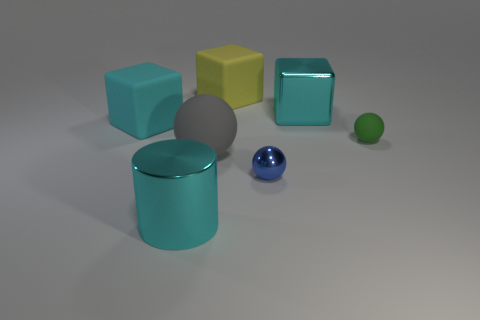Are there fewer shiny cubes that are behind the blue metal thing than blue balls?
Keep it short and to the point. No. What is the shape of the large cyan thing that is to the right of the large cyan cylinder?
Provide a succinct answer. Cube. What is the shape of the other matte object that is the same size as the blue object?
Ensure brevity in your answer.  Sphere. Is there another big rubber object of the same shape as the blue object?
Offer a very short reply. Yes. Is the shape of the big cyan object left of the metallic cylinder the same as the large cyan object that is right of the large gray object?
Provide a short and direct response. Yes. There is a green object that is the same size as the blue sphere; what is its material?
Offer a terse response. Rubber. How many other things are there of the same material as the large cylinder?
Your answer should be very brief. 2. There is a tiny object in front of the tiny rubber ball behind the tiny blue shiny object; what is its shape?
Your answer should be compact. Sphere. What number of things are big cyan matte things or cyan cubes that are left of the small matte ball?
Provide a succinct answer. 2. What number of other objects are there of the same color as the large ball?
Keep it short and to the point. 0. 